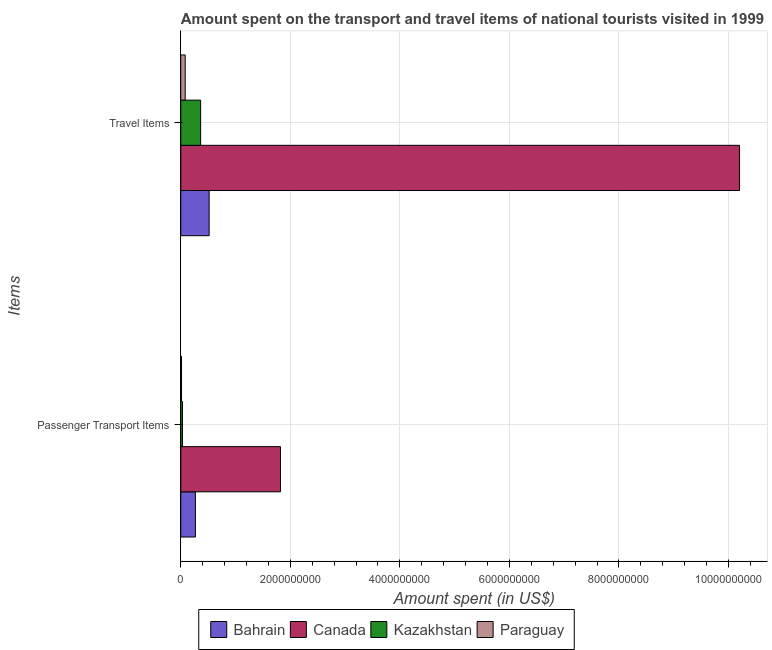How many different coloured bars are there?
Ensure brevity in your answer.  4. How many bars are there on the 2nd tick from the bottom?
Offer a terse response. 4. What is the label of the 2nd group of bars from the top?
Make the answer very short. Passenger Transport Items. What is the amount spent in travel items in Canada?
Keep it short and to the point. 1.02e+1. Across all countries, what is the maximum amount spent on passenger transport items?
Offer a terse response. 1.82e+09. Across all countries, what is the minimum amount spent on passenger transport items?
Keep it short and to the point. 1.40e+07. In which country was the amount spent in travel items minimum?
Offer a very short reply. Paraguay. What is the total amount spent on passenger transport items in the graph?
Make the answer very short. 2.13e+09. What is the difference between the amount spent in travel items in Paraguay and that in Canada?
Offer a very short reply. -1.01e+1. What is the difference between the amount spent in travel items in Kazakhstan and the amount spent on passenger transport items in Paraguay?
Your answer should be compact. 3.49e+08. What is the average amount spent on passenger transport items per country?
Your answer should be compact. 5.33e+08. What is the difference between the amount spent in travel items and amount spent on passenger transport items in Paraguay?
Make the answer very short. 6.70e+07. In how many countries, is the amount spent in travel items greater than 5200000000 US$?
Offer a terse response. 1. What is the ratio of the amount spent on passenger transport items in Bahrain to that in Canada?
Keep it short and to the point. 0.15. What does the 2nd bar from the top in Travel Items represents?
Give a very brief answer. Kazakhstan. What does the 4th bar from the bottom in Passenger Transport Items represents?
Your response must be concise. Paraguay. What is the difference between two consecutive major ticks on the X-axis?
Your answer should be very brief. 2.00e+09. Are the values on the major ticks of X-axis written in scientific E-notation?
Ensure brevity in your answer.  No. Does the graph contain grids?
Ensure brevity in your answer.  Yes. Where does the legend appear in the graph?
Keep it short and to the point. Bottom center. What is the title of the graph?
Ensure brevity in your answer.  Amount spent on the transport and travel items of national tourists visited in 1999. Does "Sub-Saharan Africa (developing only)" appear as one of the legend labels in the graph?
Offer a very short reply. No. What is the label or title of the X-axis?
Your answer should be compact. Amount spent (in US$). What is the label or title of the Y-axis?
Give a very brief answer. Items. What is the Amount spent (in US$) of Bahrain in Passenger Transport Items?
Your response must be concise. 2.67e+08. What is the Amount spent (in US$) in Canada in Passenger Transport Items?
Your response must be concise. 1.82e+09. What is the Amount spent (in US$) in Kazakhstan in Passenger Transport Items?
Keep it short and to the point. 3.10e+07. What is the Amount spent (in US$) of Paraguay in Passenger Transport Items?
Offer a terse response. 1.40e+07. What is the Amount spent (in US$) in Bahrain in Travel Items?
Your answer should be very brief. 5.18e+08. What is the Amount spent (in US$) in Canada in Travel Items?
Offer a terse response. 1.02e+1. What is the Amount spent (in US$) of Kazakhstan in Travel Items?
Your answer should be very brief. 3.63e+08. What is the Amount spent (in US$) in Paraguay in Travel Items?
Your answer should be compact. 8.10e+07. Across all Items, what is the maximum Amount spent (in US$) in Bahrain?
Ensure brevity in your answer.  5.18e+08. Across all Items, what is the maximum Amount spent (in US$) in Canada?
Offer a terse response. 1.02e+1. Across all Items, what is the maximum Amount spent (in US$) in Kazakhstan?
Offer a terse response. 3.63e+08. Across all Items, what is the maximum Amount spent (in US$) of Paraguay?
Keep it short and to the point. 8.10e+07. Across all Items, what is the minimum Amount spent (in US$) of Bahrain?
Offer a terse response. 2.67e+08. Across all Items, what is the minimum Amount spent (in US$) of Canada?
Provide a short and direct response. 1.82e+09. Across all Items, what is the minimum Amount spent (in US$) in Kazakhstan?
Give a very brief answer. 3.10e+07. Across all Items, what is the minimum Amount spent (in US$) of Paraguay?
Offer a terse response. 1.40e+07. What is the total Amount spent (in US$) in Bahrain in the graph?
Offer a very short reply. 7.85e+08. What is the total Amount spent (in US$) in Canada in the graph?
Offer a very short reply. 1.20e+1. What is the total Amount spent (in US$) of Kazakhstan in the graph?
Ensure brevity in your answer.  3.94e+08. What is the total Amount spent (in US$) of Paraguay in the graph?
Offer a terse response. 9.50e+07. What is the difference between the Amount spent (in US$) in Bahrain in Passenger Transport Items and that in Travel Items?
Give a very brief answer. -2.51e+08. What is the difference between the Amount spent (in US$) of Canada in Passenger Transport Items and that in Travel Items?
Make the answer very short. -8.38e+09. What is the difference between the Amount spent (in US$) of Kazakhstan in Passenger Transport Items and that in Travel Items?
Provide a short and direct response. -3.32e+08. What is the difference between the Amount spent (in US$) of Paraguay in Passenger Transport Items and that in Travel Items?
Give a very brief answer. -6.70e+07. What is the difference between the Amount spent (in US$) in Bahrain in Passenger Transport Items and the Amount spent (in US$) in Canada in Travel Items?
Your response must be concise. -9.94e+09. What is the difference between the Amount spent (in US$) of Bahrain in Passenger Transport Items and the Amount spent (in US$) of Kazakhstan in Travel Items?
Ensure brevity in your answer.  -9.60e+07. What is the difference between the Amount spent (in US$) of Bahrain in Passenger Transport Items and the Amount spent (in US$) of Paraguay in Travel Items?
Keep it short and to the point. 1.86e+08. What is the difference between the Amount spent (in US$) in Canada in Passenger Transport Items and the Amount spent (in US$) in Kazakhstan in Travel Items?
Give a very brief answer. 1.46e+09. What is the difference between the Amount spent (in US$) of Canada in Passenger Transport Items and the Amount spent (in US$) of Paraguay in Travel Items?
Give a very brief answer. 1.74e+09. What is the difference between the Amount spent (in US$) of Kazakhstan in Passenger Transport Items and the Amount spent (in US$) of Paraguay in Travel Items?
Provide a short and direct response. -5.00e+07. What is the average Amount spent (in US$) in Bahrain per Items?
Offer a very short reply. 3.92e+08. What is the average Amount spent (in US$) of Canada per Items?
Your answer should be compact. 6.01e+09. What is the average Amount spent (in US$) of Kazakhstan per Items?
Provide a succinct answer. 1.97e+08. What is the average Amount spent (in US$) of Paraguay per Items?
Your answer should be very brief. 4.75e+07. What is the difference between the Amount spent (in US$) of Bahrain and Amount spent (in US$) of Canada in Passenger Transport Items?
Provide a short and direct response. -1.55e+09. What is the difference between the Amount spent (in US$) in Bahrain and Amount spent (in US$) in Kazakhstan in Passenger Transport Items?
Provide a short and direct response. 2.36e+08. What is the difference between the Amount spent (in US$) of Bahrain and Amount spent (in US$) of Paraguay in Passenger Transport Items?
Make the answer very short. 2.53e+08. What is the difference between the Amount spent (in US$) in Canada and Amount spent (in US$) in Kazakhstan in Passenger Transport Items?
Provide a short and direct response. 1.79e+09. What is the difference between the Amount spent (in US$) in Canada and Amount spent (in US$) in Paraguay in Passenger Transport Items?
Your answer should be very brief. 1.81e+09. What is the difference between the Amount spent (in US$) in Kazakhstan and Amount spent (in US$) in Paraguay in Passenger Transport Items?
Give a very brief answer. 1.70e+07. What is the difference between the Amount spent (in US$) in Bahrain and Amount spent (in US$) in Canada in Travel Items?
Ensure brevity in your answer.  -9.68e+09. What is the difference between the Amount spent (in US$) of Bahrain and Amount spent (in US$) of Kazakhstan in Travel Items?
Ensure brevity in your answer.  1.55e+08. What is the difference between the Amount spent (in US$) of Bahrain and Amount spent (in US$) of Paraguay in Travel Items?
Provide a succinct answer. 4.37e+08. What is the difference between the Amount spent (in US$) of Canada and Amount spent (in US$) of Kazakhstan in Travel Items?
Make the answer very short. 9.84e+09. What is the difference between the Amount spent (in US$) of Canada and Amount spent (in US$) of Paraguay in Travel Items?
Provide a short and direct response. 1.01e+1. What is the difference between the Amount spent (in US$) in Kazakhstan and Amount spent (in US$) in Paraguay in Travel Items?
Make the answer very short. 2.82e+08. What is the ratio of the Amount spent (in US$) of Bahrain in Passenger Transport Items to that in Travel Items?
Provide a short and direct response. 0.52. What is the ratio of the Amount spent (in US$) of Canada in Passenger Transport Items to that in Travel Items?
Ensure brevity in your answer.  0.18. What is the ratio of the Amount spent (in US$) in Kazakhstan in Passenger Transport Items to that in Travel Items?
Make the answer very short. 0.09. What is the ratio of the Amount spent (in US$) of Paraguay in Passenger Transport Items to that in Travel Items?
Give a very brief answer. 0.17. What is the difference between the highest and the second highest Amount spent (in US$) in Bahrain?
Offer a terse response. 2.51e+08. What is the difference between the highest and the second highest Amount spent (in US$) in Canada?
Your response must be concise. 8.38e+09. What is the difference between the highest and the second highest Amount spent (in US$) of Kazakhstan?
Ensure brevity in your answer.  3.32e+08. What is the difference between the highest and the second highest Amount spent (in US$) of Paraguay?
Your answer should be very brief. 6.70e+07. What is the difference between the highest and the lowest Amount spent (in US$) in Bahrain?
Give a very brief answer. 2.51e+08. What is the difference between the highest and the lowest Amount spent (in US$) in Canada?
Offer a very short reply. 8.38e+09. What is the difference between the highest and the lowest Amount spent (in US$) of Kazakhstan?
Your answer should be compact. 3.32e+08. What is the difference between the highest and the lowest Amount spent (in US$) of Paraguay?
Provide a succinct answer. 6.70e+07. 